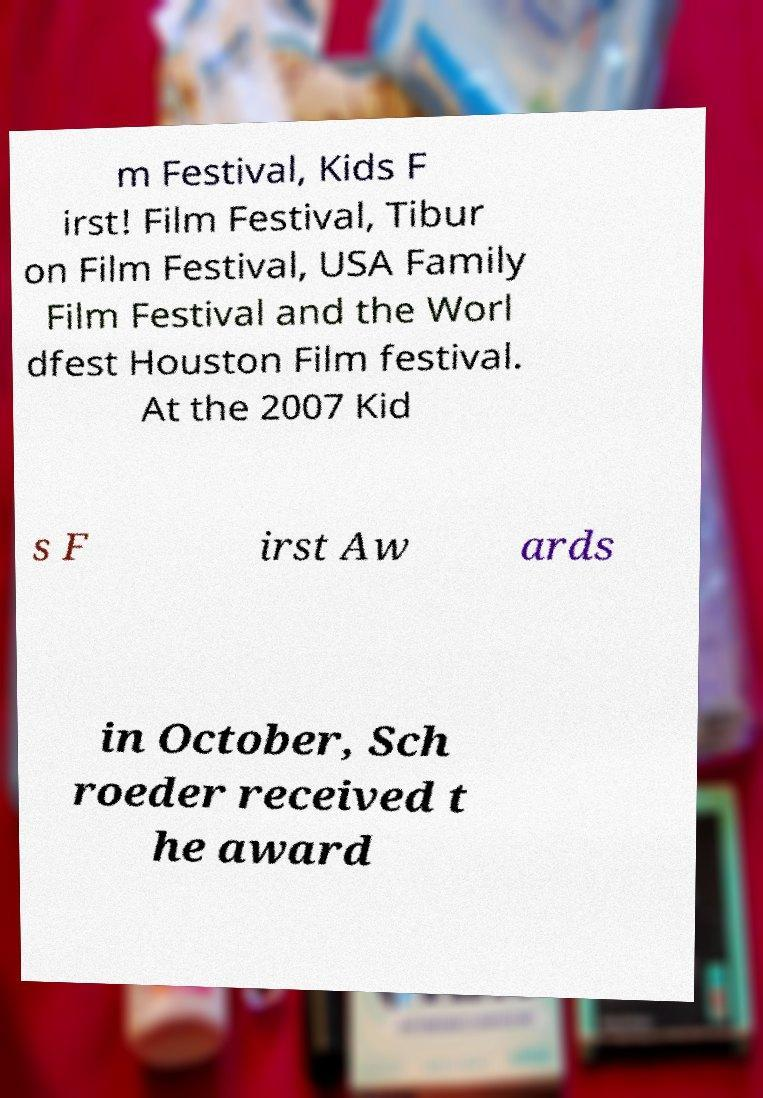Could you assist in decoding the text presented in this image and type it out clearly? m Festival, Kids F irst! Film Festival, Tibur on Film Festival, USA Family Film Festival and the Worl dfest Houston Film festival. At the 2007 Kid s F irst Aw ards in October, Sch roeder received t he award 